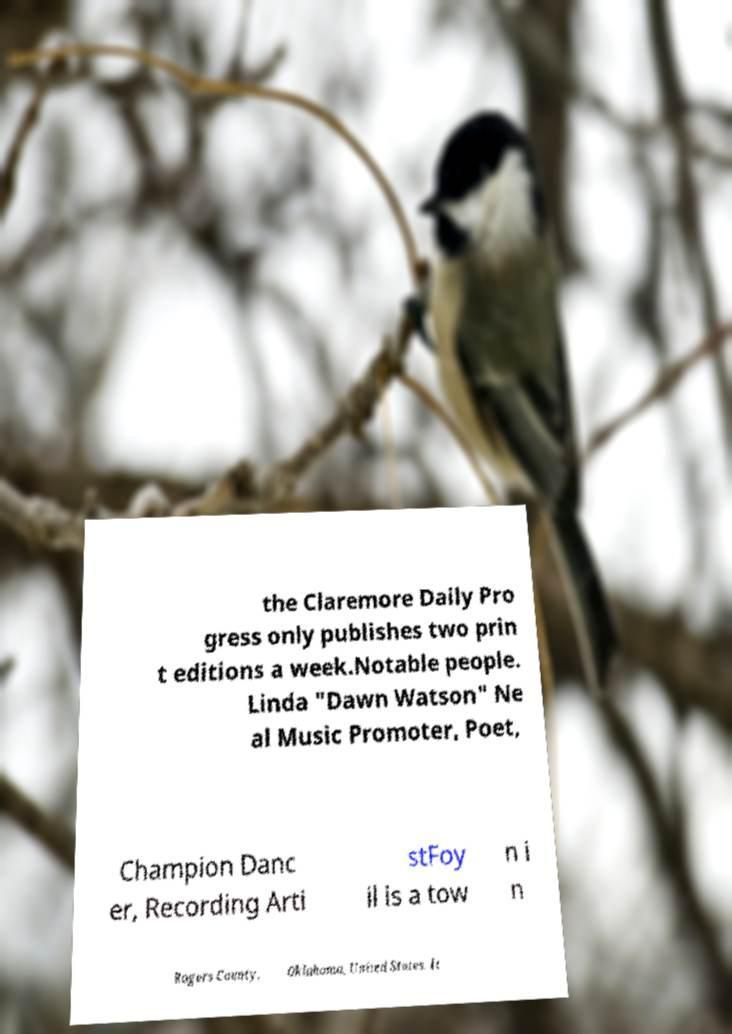Can you read and provide the text displayed in the image?This photo seems to have some interesting text. Can you extract and type it out for me? the Claremore Daily Pro gress only publishes two prin t editions a week.Notable people. Linda "Dawn Watson" Ne al Music Promoter, Poet, Champion Danc er, Recording Arti stFoy il is a tow n i n Rogers County, Oklahoma, United States. It 